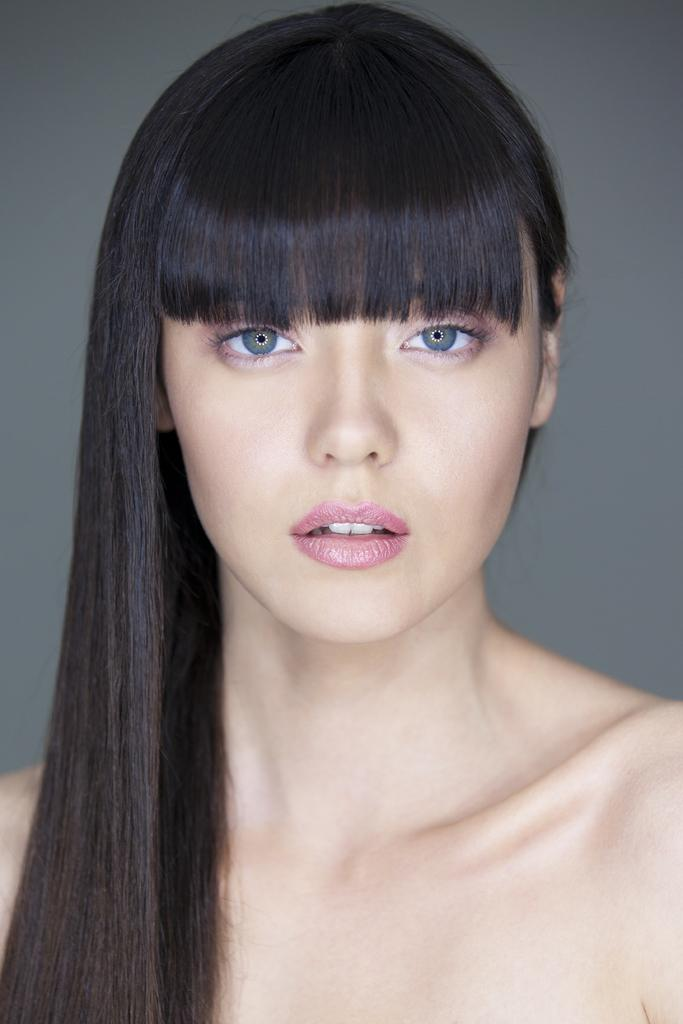Who is the main subject in the image? There is a woman in the picture. What can be seen behind the woman in the image? The background of the image is plain. What type of sweater is the woman wearing in the image? There is no information about the woman's clothing in the provided facts, so we cannot determine if she is wearing a sweater or not. What event related to death is depicted in the image? There is no mention of death or any related event in the provided facts, so we cannot answer this question. 